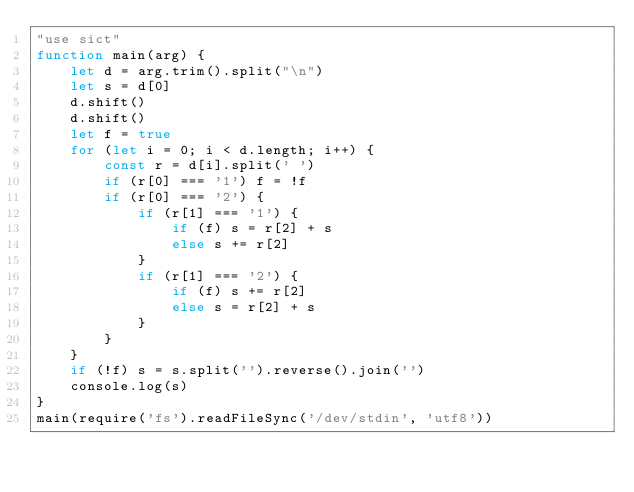<code> <loc_0><loc_0><loc_500><loc_500><_JavaScript_>"use sict"
function main(arg) {
    let d = arg.trim().split("\n")
    let s = d[0]
    d.shift()
    d.shift()
    let f = true
    for (let i = 0; i < d.length; i++) {
        const r = d[i].split(' ')
        if (r[0] === '1') f = !f
        if (r[0] === '2') {
            if (r[1] === '1') {
                if (f) s = r[2] + s
                else s += r[2]
            }
            if (r[1] === '2') {
                if (f) s += r[2]
                else s = r[2] + s
            }
        }
    }
    if (!f) s = s.split('').reverse().join('')
    console.log(s)
}
main(require('fs').readFileSync('/dev/stdin', 'utf8'))
</code> 